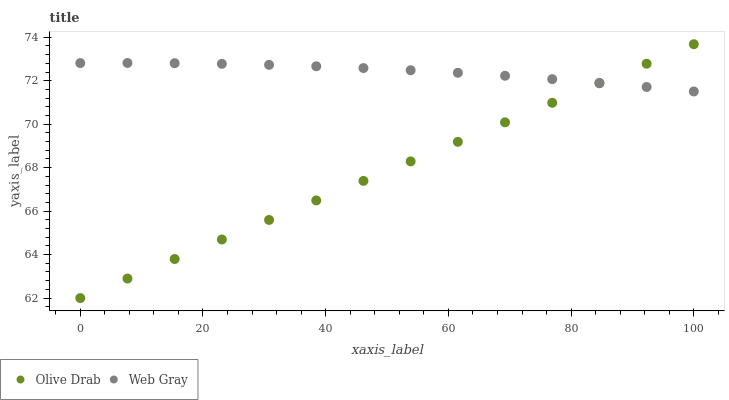Does Olive Drab have the minimum area under the curve?
Answer yes or no. Yes. Does Web Gray have the maximum area under the curve?
Answer yes or no. Yes. Does Olive Drab have the maximum area under the curve?
Answer yes or no. No. Is Olive Drab the smoothest?
Answer yes or no. Yes. Is Web Gray the roughest?
Answer yes or no. Yes. Is Olive Drab the roughest?
Answer yes or no. No. Does Olive Drab have the lowest value?
Answer yes or no. Yes. Does Olive Drab have the highest value?
Answer yes or no. Yes. Does Olive Drab intersect Web Gray?
Answer yes or no. Yes. Is Olive Drab less than Web Gray?
Answer yes or no. No. Is Olive Drab greater than Web Gray?
Answer yes or no. No. 